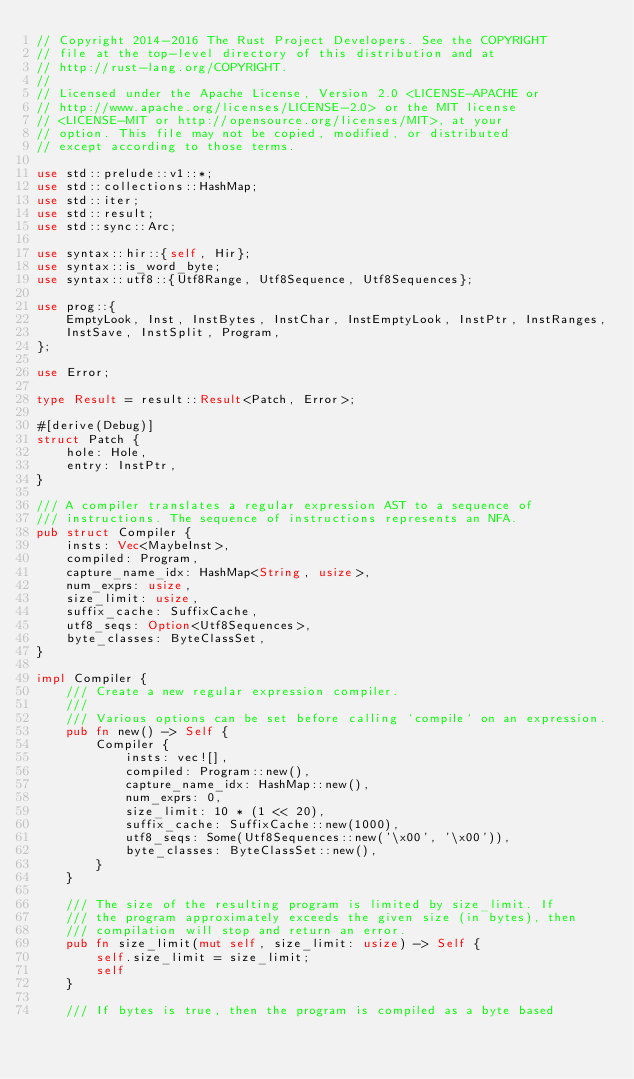Convert code to text. <code><loc_0><loc_0><loc_500><loc_500><_Rust_>// Copyright 2014-2016 The Rust Project Developers. See the COPYRIGHT
// file at the top-level directory of this distribution and at
// http://rust-lang.org/COPYRIGHT.
//
// Licensed under the Apache License, Version 2.0 <LICENSE-APACHE or
// http://www.apache.org/licenses/LICENSE-2.0> or the MIT license
// <LICENSE-MIT or http://opensource.org/licenses/MIT>, at your
// option. This file may not be copied, modified, or distributed
// except according to those terms.

use std::prelude::v1::*;
use std::collections::HashMap;
use std::iter;
use std::result;
use std::sync::Arc;

use syntax::hir::{self, Hir};
use syntax::is_word_byte;
use syntax::utf8::{Utf8Range, Utf8Sequence, Utf8Sequences};

use prog::{
    EmptyLook, Inst, InstBytes, InstChar, InstEmptyLook, InstPtr, InstRanges,
    InstSave, InstSplit, Program,
};

use Error;

type Result = result::Result<Patch, Error>;

#[derive(Debug)]
struct Patch {
    hole: Hole,
    entry: InstPtr,
}

/// A compiler translates a regular expression AST to a sequence of
/// instructions. The sequence of instructions represents an NFA.
pub struct Compiler {
    insts: Vec<MaybeInst>,
    compiled: Program,
    capture_name_idx: HashMap<String, usize>,
    num_exprs: usize,
    size_limit: usize,
    suffix_cache: SuffixCache,
    utf8_seqs: Option<Utf8Sequences>,
    byte_classes: ByteClassSet,
}

impl Compiler {
    /// Create a new regular expression compiler.
    ///
    /// Various options can be set before calling `compile` on an expression.
    pub fn new() -> Self {
        Compiler {
            insts: vec![],
            compiled: Program::new(),
            capture_name_idx: HashMap::new(),
            num_exprs: 0,
            size_limit: 10 * (1 << 20),
            suffix_cache: SuffixCache::new(1000),
            utf8_seqs: Some(Utf8Sequences::new('\x00', '\x00')),
            byte_classes: ByteClassSet::new(),
        }
    }

    /// The size of the resulting program is limited by size_limit. If
    /// the program approximately exceeds the given size (in bytes), then
    /// compilation will stop and return an error.
    pub fn size_limit(mut self, size_limit: usize) -> Self {
        self.size_limit = size_limit;
        self
    }

    /// If bytes is true, then the program is compiled as a byte based</code> 